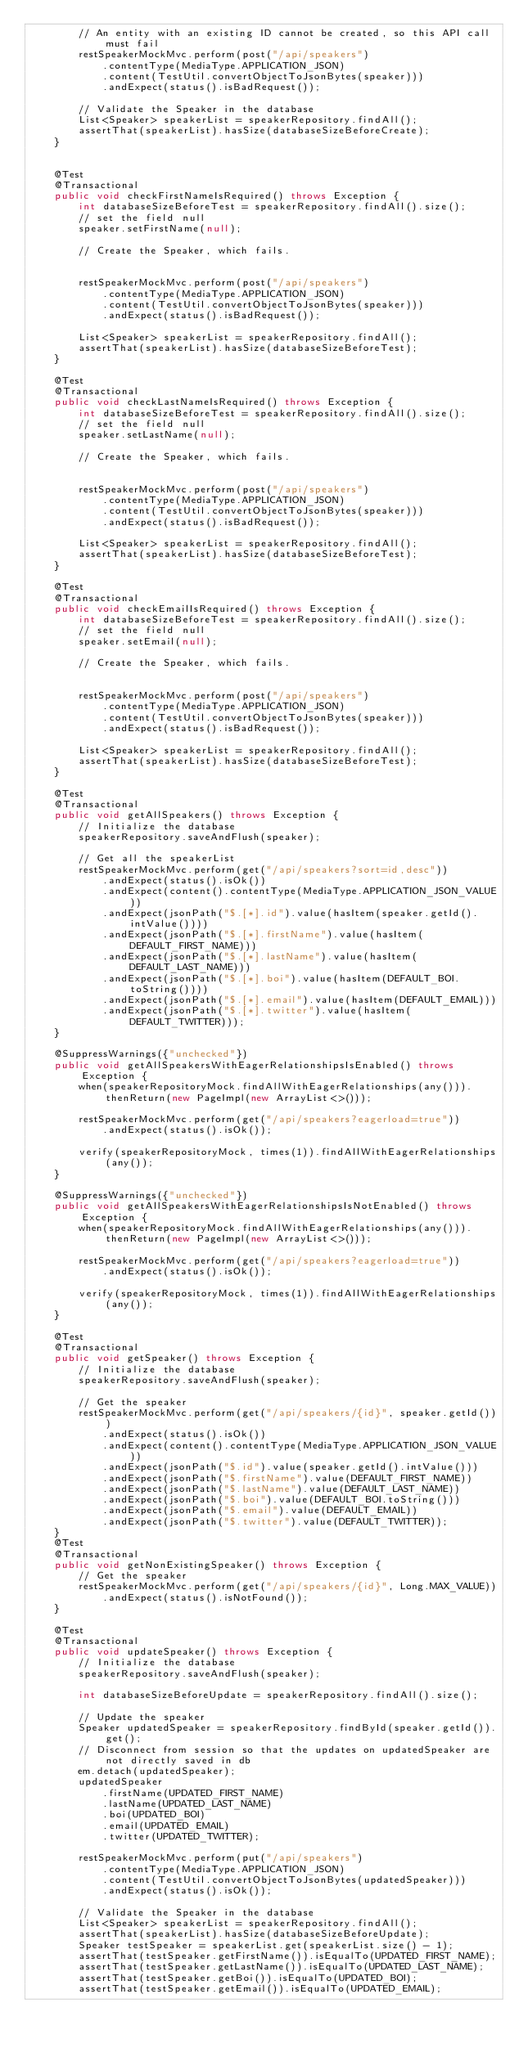Convert code to text. <code><loc_0><loc_0><loc_500><loc_500><_Java_>        // An entity with an existing ID cannot be created, so this API call must fail
        restSpeakerMockMvc.perform(post("/api/speakers")
            .contentType(MediaType.APPLICATION_JSON)
            .content(TestUtil.convertObjectToJsonBytes(speaker)))
            .andExpect(status().isBadRequest());

        // Validate the Speaker in the database
        List<Speaker> speakerList = speakerRepository.findAll();
        assertThat(speakerList).hasSize(databaseSizeBeforeCreate);
    }


    @Test
    @Transactional
    public void checkFirstNameIsRequired() throws Exception {
        int databaseSizeBeforeTest = speakerRepository.findAll().size();
        // set the field null
        speaker.setFirstName(null);

        // Create the Speaker, which fails.


        restSpeakerMockMvc.perform(post("/api/speakers")
            .contentType(MediaType.APPLICATION_JSON)
            .content(TestUtil.convertObjectToJsonBytes(speaker)))
            .andExpect(status().isBadRequest());

        List<Speaker> speakerList = speakerRepository.findAll();
        assertThat(speakerList).hasSize(databaseSizeBeforeTest);
    }

    @Test
    @Transactional
    public void checkLastNameIsRequired() throws Exception {
        int databaseSizeBeforeTest = speakerRepository.findAll().size();
        // set the field null
        speaker.setLastName(null);

        // Create the Speaker, which fails.


        restSpeakerMockMvc.perform(post("/api/speakers")
            .contentType(MediaType.APPLICATION_JSON)
            .content(TestUtil.convertObjectToJsonBytes(speaker)))
            .andExpect(status().isBadRequest());

        List<Speaker> speakerList = speakerRepository.findAll();
        assertThat(speakerList).hasSize(databaseSizeBeforeTest);
    }

    @Test
    @Transactional
    public void checkEmailIsRequired() throws Exception {
        int databaseSizeBeforeTest = speakerRepository.findAll().size();
        // set the field null
        speaker.setEmail(null);

        // Create the Speaker, which fails.


        restSpeakerMockMvc.perform(post("/api/speakers")
            .contentType(MediaType.APPLICATION_JSON)
            .content(TestUtil.convertObjectToJsonBytes(speaker)))
            .andExpect(status().isBadRequest());

        List<Speaker> speakerList = speakerRepository.findAll();
        assertThat(speakerList).hasSize(databaseSizeBeforeTest);
    }

    @Test
    @Transactional
    public void getAllSpeakers() throws Exception {
        // Initialize the database
        speakerRepository.saveAndFlush(speaker);

        // Get all the speakerList
        restSpeakerMockMvc.perform(get("/api/speakers?sort=id,desc"))
            .andExpect(status().isOk())
            .andExpect(content().contentType(MediaType.APPLICATION_JSON_VALUE))
            .andExpect(jsonPath("$.[*].id").value(hasItem(speaker.getId().intValue())))
            .andExpect(jsonPath("$.[*].firstName").value(hasItem(DEFAULT_FIRST_NAME)))
            .andExpect(jsonPath("$.[*].lastName").value(hasItem(DEFAULT_LAST_NAME)))
            .andExpect(jsonPath("$.[*].boi").value(hasItem(DEFAULT_BOI.toString())))
            .andExpect(jsonPath("$.[*].email").value(hasItem(DEFAULT_EMAIL)))
            .andExpect(jsonPath("$.[*].twitter").value(hasItem(DEFAULT_TWITTER)));
    }
    
    @SuppressWarnings({"unchecked"})
    public void getAllSpeakersWithEagerRelationshipsIsEnabled() throws Exception {
        when(speakerRepositoryMock.findAllWithEagerRelationships(any())).thenReturn(new PageImpl(new ArrayList<>()));

        restSpeakerMockMvc.perform(get("/api/speakers?eagerload=true"))
            .andExpect(status().isOk());

        verify(speakerRepositoryMock, times(1)).findAllWithEagerRelationships(any());
    }

    @SuppressWarnings({"unchecked"})
    public void getAllSpeakersWithEagerRelationshipsIsNotEnabled() throws Exception {
        when(speakerRepositoryMock.findAllWithEagerRelationships(any())).thenReturn(new PageImpl(new ArrayList<>()));

        restSpeakerMockMvc.perform(get("/api/speakers?eagerload=true"))
            .andExpect(status().isOk());

        verify(speakerRepositoryMock, times(1)).findAllWithEagerRelationships(any());
    }

    @Test
    @Transactional
    public void getSpeaker() throws Exception {
        // Initialize the database
        speakerRepository.saveAndFlush(speaker);

        // Get the speaker
        restSpeakerMockMvc.perform(get("/api/speakers/{id}", speaker.getId()))
            .andExpect(status().isOk())
            .andExpect(content().contentType(MediaType.APPLICATION_JSON_VALUE))
            .andExpect(jsonPath("$.id").value(speaker.getId().intValue()))
            .andExpect(jsonPath("$.firstName").value(DEFAULT_FIRST_NAME))
            .andExpect(jsonPath("$.lastName").value(DEFAULT_LAST_NAME))
            .andExpect(jsonPath("$.boi").value(DEFAULT_BOI.toString()))
            .andExpect(jsonPath("$.email").value(DEFAULT_EMAIL))
            .andExpect(jsonPath("$.twitter").value(DEFAULT_TWITTER));
    }
    @Test
    @Transactional
    public void getNonExistingSpeaker() throws Exception {
        // Get the speaker
        restSpeakerMockMvc.perform(get("/api/speakers/{id}", Long.MAX_VALUE))
            .andExpect(status().isNotFound());
    }

    @Test
    @Transactional
    public void updateSpeaker() throws Exception {
        // Initialize the database
        speakerRepository.saveAndFlush(speaker);

        int databaseSizeBeforeUpdate = speakerRepository.findAll().size();

        // Update the speaker
        Speaker updatedSpeaker = speakerRepository.findById(speaker.getId()).get();
        // Disconnect from session so that the updates on updatedSpeaker are not directly saved in db
        em.detach(updatedSpeaker);
        updatedSpeaker
            .firstName(UPDATED_FIRST_NAME)
            .lastName(UPDATED_LAST_NAME)
            .boi(UPDATED_BOI)
            .email(UPDATED_EMAIL)
            .twitter(UPDATED_TWITTER);

        restSpeakerMockMvc.perform(put("/api/speakers")
            .contentType(MediaType.APPLICATION_JSON)
            .content(TestUtil.convertObjectToJsonBytes(updatedSpeaker)))
            .andExpect(status().isOk());

        // Validate the Speaker in the database
        List<Speaker> speakerList = speakerRepository.findAll();
        assertThat(speakerList).hasSize(databaseSizeBeforeUpdate);
        Speaker testSpeaker = speakerList.get(speakerList.size() - 1);
        assertThat(testSpeaker.getFirstName()).isEqualTo(UPDATED_FIRST_NAME);
        assertThat(testSpeaker.getLastName()).isEqualTo(UPDATED_LAST_NAME);
        assertThat(testSpeaker.getBoi()).isEqualTo(UPDATED_BOI);
        assertThat(testSpeaker.getEmail()).isEqualTo(UPDATED_EMAIL);</code> 